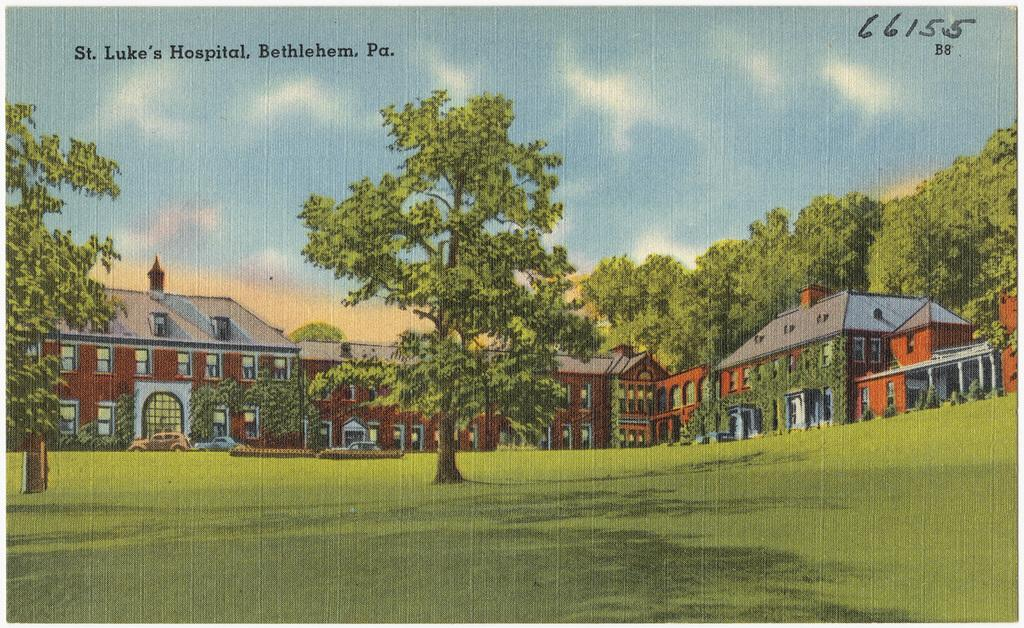What type of structures can be seen in the image? There are buildings in the image. What else can be seen in the image besides the buildings? There are trees in the image. Is there any text present in the image? Yes, there is a text in the top left of the image. What can be seen in the background of the image? The sky is visible in the background of the image. What advice does the book in the image give to the reader? There is no book present in the image, so no advice can be given. 